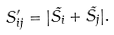<formula> <loc_0><loc_0><loc_500><loc_500>S ^ { \prime } _ { i j } = | \vec { S _ { i } } + \vec { S _ { j } } | .</formula> 